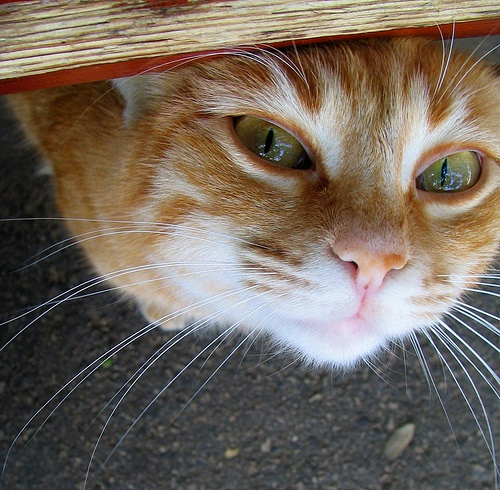Describe the objects in this image and their specific colors. I can see a cat in maroon, lightgray, gray, and darkgray tones in this image. 